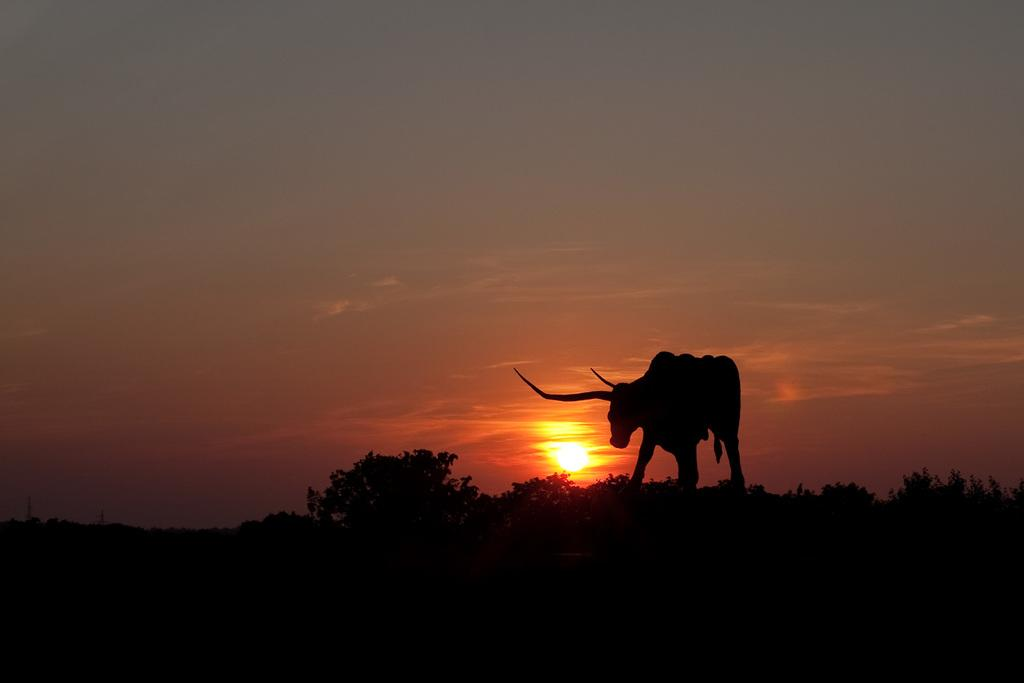What is the overall lighting condition in the image? The image is dark. What can be seen on the surface in the image? There is an animal on the surface in the image. What type of natural vegetation is present in the image? There are trees in the image. What is visible in the distance in the image? The sky is visible in the background of the image. How much wealth is depicted in the image? There is no depiction of wealth in the image; it features an animal, trees, and a dark background. Can you tell me how many copies of the jar are present in the image? There is no jar present in the image. 